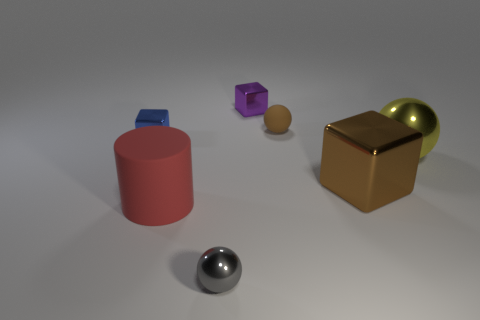Add 3 brown metallic objects. How many objects exist? 10 Subtract all yellow spheres. How many spheres are left? 2 Subtract all tiny cubes. How many cubes are left? 1 Subtract 0 green cylinders. How many objects are left? 7 Subtract all cylinders. How many objects are left? 6 Subtract all blue cubes. Subtract all gray balls. How many cubes are left? 2 Subtract all green spheres. How many brown cubes are left? 1 Subtract all small purple metal blocks. Subtract all tiny blue shiny cubes. How many objects are left? 5 Add 5 brown shiny cubes. How many brown shiny cubes are left? 6 Add 5 big metal blocks. How many big metal blocks exist? 6 